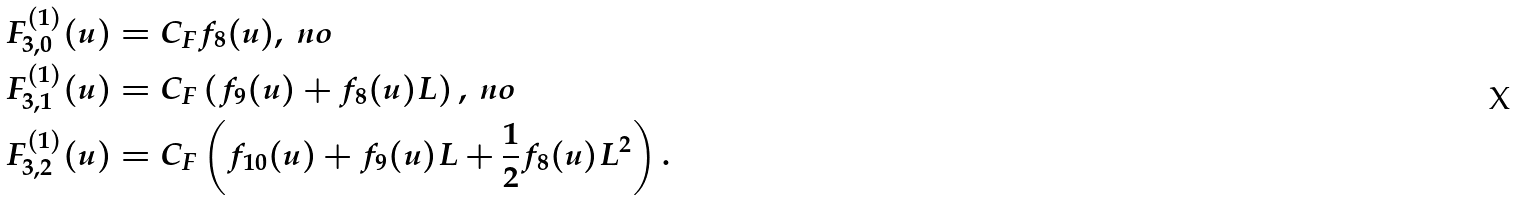Convert formula to latex. <formula><loc_0><loc_0><loc_500><loc_500>F _ { 3 , 0 } ^ { ( 1 ) } ( u ) & = C _ { F } f _ { 8 } ( u ) , \ n o \\ F _ { 3 , 1 } ^ { ( 1 ) } ( u ) & = C _ { F } \left ( f _ { 9 } ( u ) + f _ { 8 } ( u ) L \right ) , \ n o \\ F _ { 3 , 2 } ^ { ( 1 ) } ( u ) & = C _ { F } \left ( f _ { 1 0 } ( u ) + f _ { 9 } ( u ) L + \frac { 1 } { 2 } f _ { 8 } ( u ) L ^ { 2 } \right ) .</formula> 